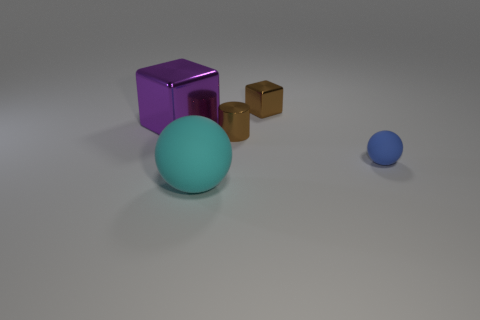Add 2 big purple metal cubes. How many objects exist? 7 Subtract all balls. How many objects are left? 3 Add 5 purple blocks. How many purple blocks are left? 6 Add 3 big purple matte balls. How many big purple matte balls exist? 3 Subtract 1 blue spheres. How many objects are left? 4 Subtract all cyan metallic cylinders. Subtract all tiny shiny blocks. How many objects are left? 4 